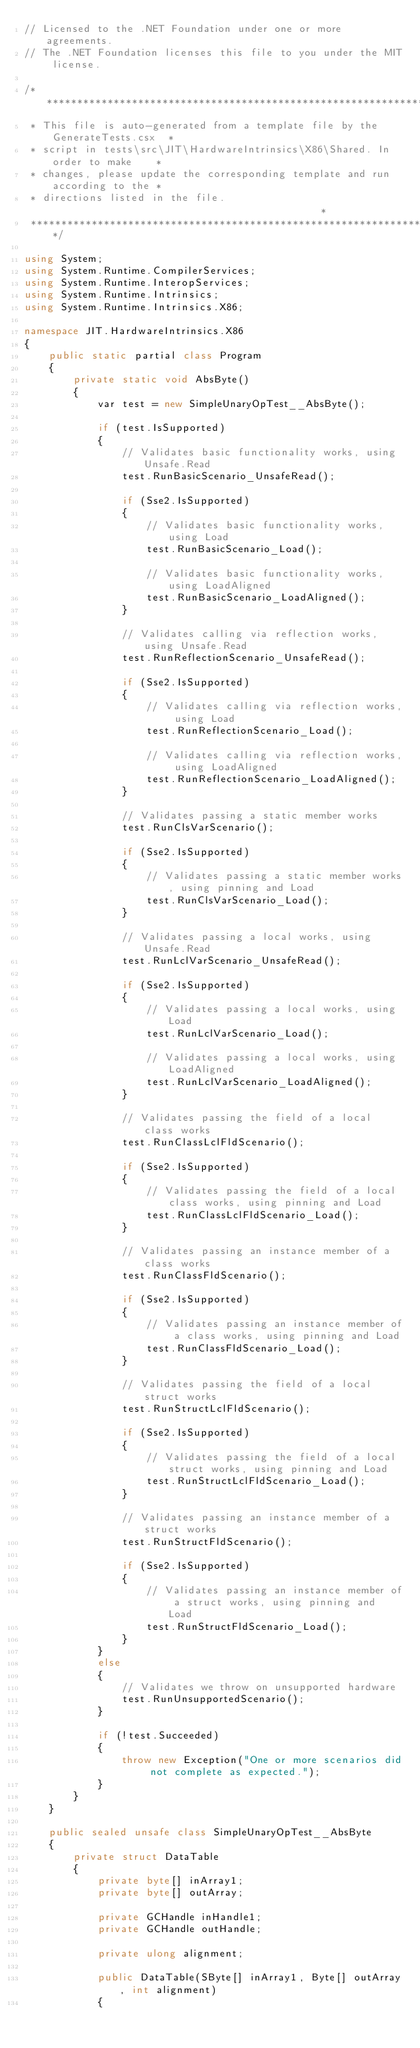<code> <loc_0><loc_0><loc_500><loc_500><_C#_>// Licensed to the .NET Foundation under one or more agreements.
// The .NET Foundation licenses this file to you under the MIT license.

/******************************************************************************
 * This file is auto-generated from a template file by the GenerateTests.csx  *
 * script in tests\src\JIT\HardwareIntrinsics\X86\Shared. In order to make    *
 * changes, please update the corresponding template and run according to the *
 * directions listed in the file.                                             *
 ******************************************************************************/

using System;
using System.Runtime.CompilerServices;
using System.Runtime.InteropServices;
using System.Runtime.Intrinsics;
using System.Runtime.Intrinsics.X86;

namespace JIT.HardwareIntrinsics.X86
{
    public static partial class Program
    {
        private static void AbsByte()
        {
            var test = new SimpleUnaryOpTest__AbsByte();

            if (test.IsSupported)
            {
                // Validates basic functionality works, using Unsafe.Read
                test.RunBasicScenario_UnsafeRead();

                if (Sse2.IsSupported)
                {
                    // Validates basic functionality works, using Load
                    test.RunBasicScenario_Load();

                    // Validates basic functionality works, using LoadAligned
                    test.RunBasicScenario_LoadAligned();
                }

                // Validates calling via reflection works, using Unsafe.Read
                test.RunReflectionScenario_UnsafeRead();

                if (Sse2.IsSupported)
                {
                    // Validates calling via reflection works, using Load
                    test.RunReflectionScenario_Load();

                    // Validates calling via reflection works, using LoadAligned
                    test.RunReflectionScenario_LoadAligned();
                }

                // Validates passing a static member works
                test.RunClsVarScenario();

                if (Sse2.IsSupported)
                {
                    // Validates passing a static member works, using pinning and Load
                    test.RunClsVarScenario_Load();
                }

                // Validates passing a local works, using Unsafe.Read
                test.RunLclVarScenario_UnsafeRead();

                if (Sse2.IsSupported)
                {
                    // Validates passing a local works, using Load
                    test.RunLclVarScenario_Load();

                    // Validates passing a local works, using LoadAligned
                    test.RunLclVarScenario_LoadAligned();
                }

                // Validates passing the field of a local class works
                test.RunClassLclFldScenario();

                if (Sse2.IsSupported)
                {
                    // Validates passing the field of a local class works, using pinning and Load
                    test.RunClassLclFldScenario_Load();
                }

                // Validates passing an instance member of a class works
                test.RunClassFldScenario();

                if (Sse2.IsSupported)
                {
                    // Validates passing an instance member of a class works, using pinning and Load
                    test.RunClassFldScenario_Load();
                }

                // Validates passing the field of a local struct works
                test.RunStructLclFldScenario();

                if (Sse2.IsSupported)
                {
                    // Validates passing the field of a local struct works, using pinning and Load
                    test.RunStructLclFldScenario_Load();
                }

                // Validates passing an instance member of a struct works
                test.RunStructFldScenario();

                if (Sse2.IsSupported)
                {
                    // Validates passing an instance member of a struct works, using pinning and Load
                    test.RunStructFldScenario_Load();
                }
            }
            else
            {
                // Validates we throw on unsupported hardware
                test.RunUnsupportedScenario();
            }

            if (!test.Succeeded)
            {
                throw new Exception("One or more scenarios did not complete as expected.");
            }
        }
    }

    public sealed unsafe class SimpleUnaryOpTest__AbsByte
    {
        private struct DataTable
        {
            private byte[] inArray1;
            private byte[] outArray;

            private GCHandle inHandle1;
            private GCHandle outHandle;

            private ulong alignment;

            public DataTable(SByte[] inArray1, Byte[] outArray, int alignment)
            {</code> 